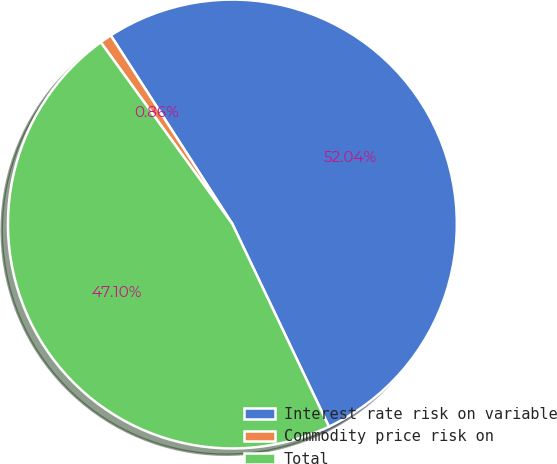<chart> <loc_0><loc_0><loc_500><loc_500><pie_chart><fcel>Interest rate risk on variable<fcel>Commodity price risk on<fcel>Total<nl><fcel>52.04%<fcel>0.86%<fcel>47.1%<nl></chart> 